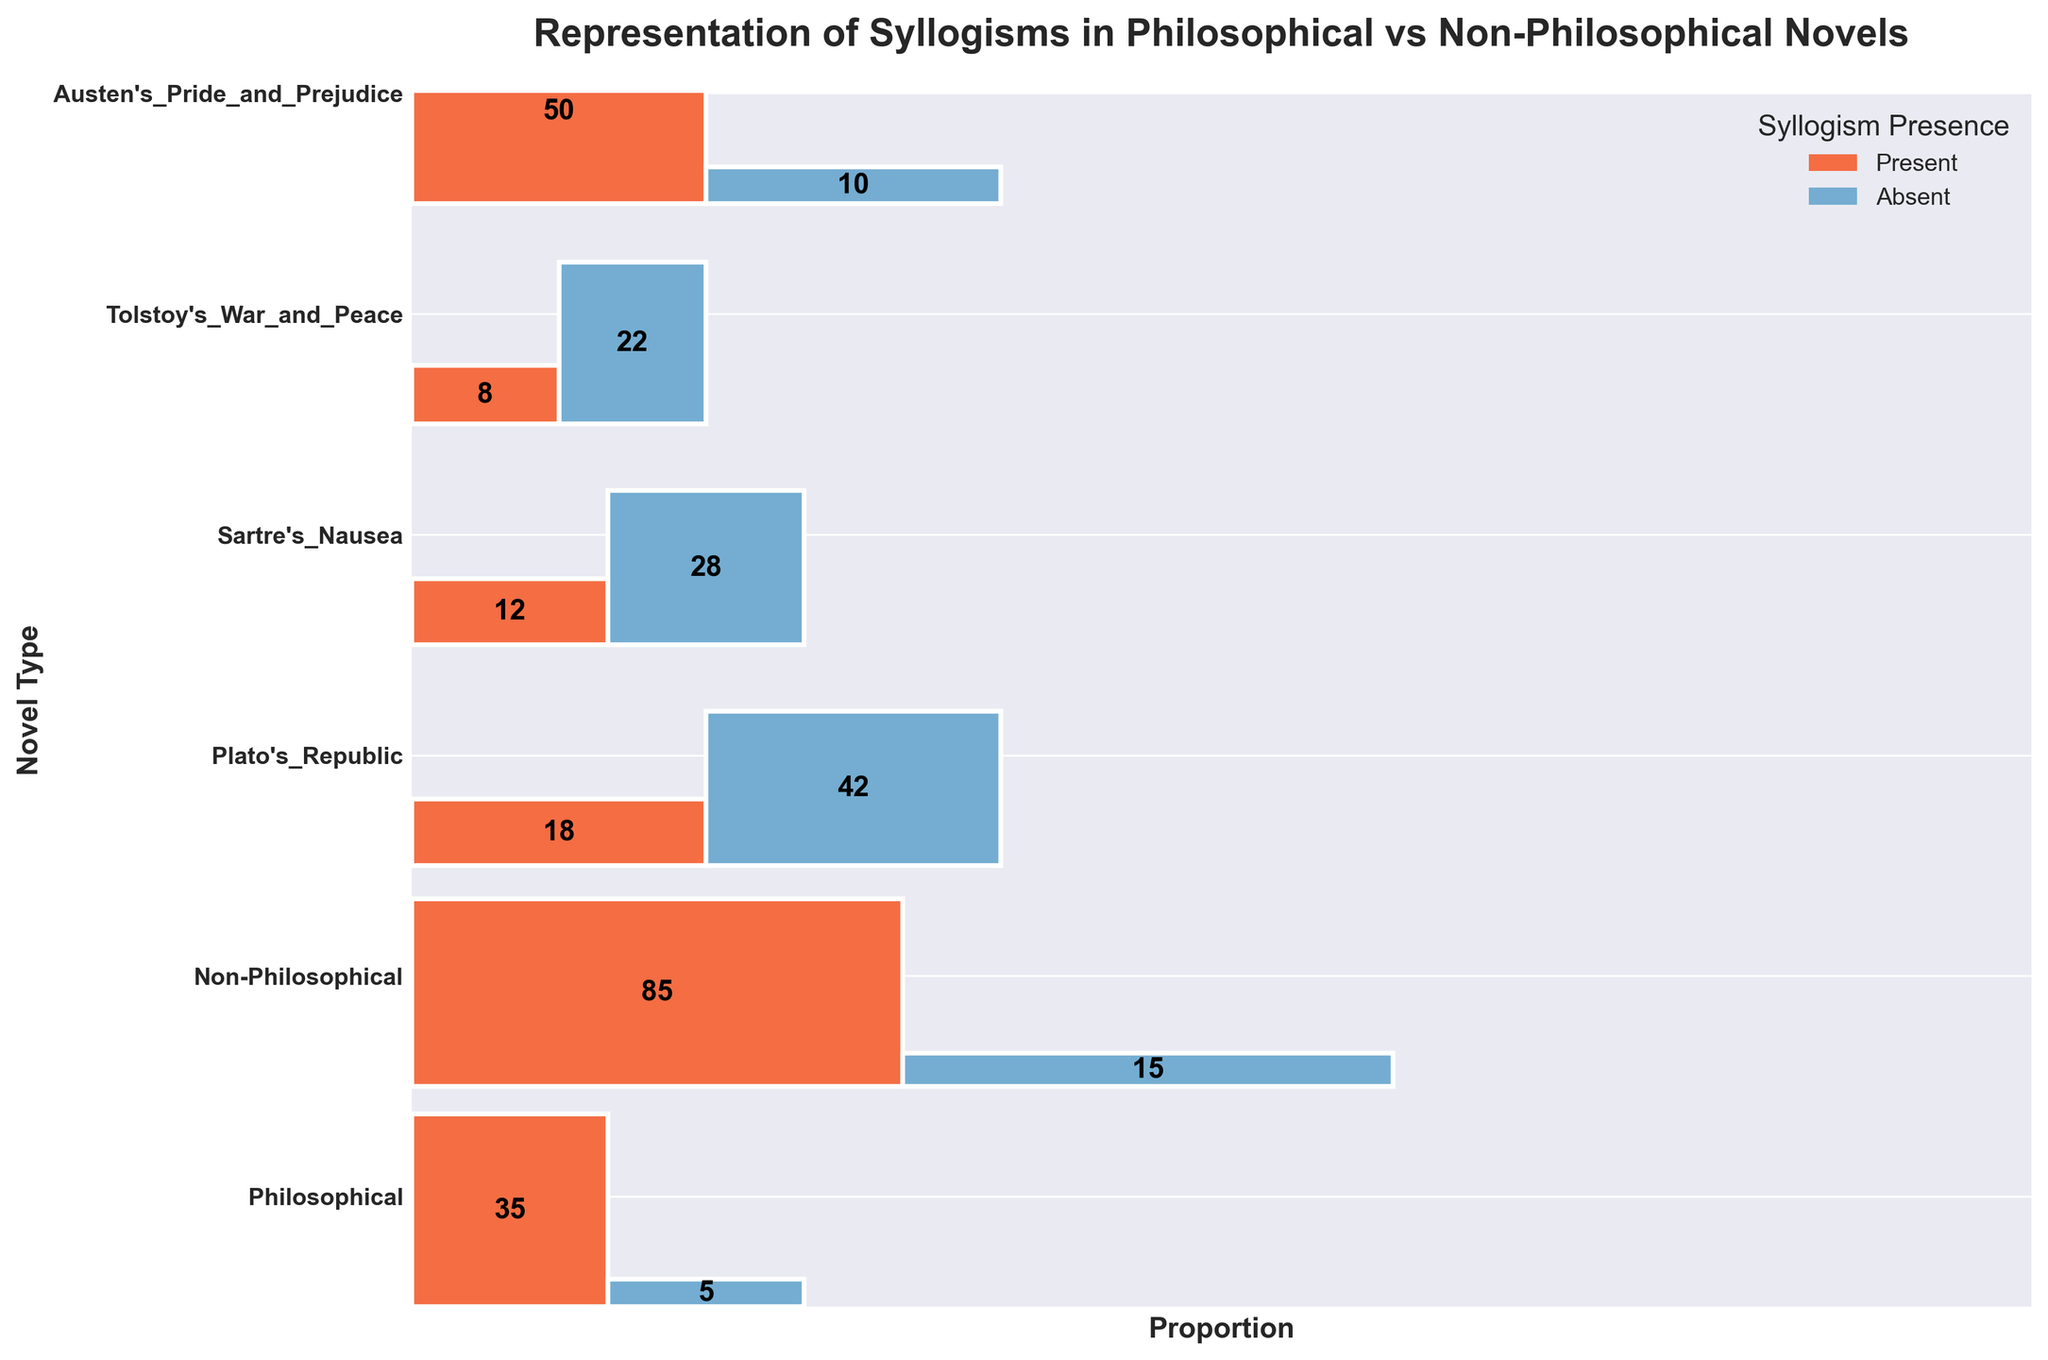What's the title of the figure? The title is displayed at the top of the plot, which reads 'Representation of Syllogisms in Philosophical vs Non-Philosophical Novels'.
Answer: Representation of Syllogisms in Philosophical vs Non-Philosophical Novels What novel is represented with the highest frequency of syllogisms present? By looking at the heights of rectangles within each row, 'Plato's Republic' shows the highest frequency, as more of the space is covered by the rectangle colored for syllogism presence.
Answer: Plato's Republic What is the proportion of syllogisms present in 'Sartre's Nausea'? The row for 'Sartre's Nausea' indicates that the light-colored rectangle is around twice as tall than that of the dark-colored, with 22 for present and 8 for absent, making the proportion 22/(22+8).
Answer: 0.73 What is the total frequency of novels with syllogisms present? Sum up the 'Present' frequencies of all novel types: 42 (Philosophical) + 15 (Non-Philosophical) + 28 (Plato's Republic) + 22 (Sartre's Nausea) + 10 (Tolstoy’s War and Peace) + 5 (Austen's Pride and Prejudice). This gives 122.
Answer: 122 Which type of novel has the greater proportion of syllogisms absent, Philosophical or Non-Philosophical? Examine the proportional widths of the rectangles for each novel type. Non-Philosophical has a larger ratio of syllogisms absent, with 85 absent versus 15 present.
Answer: Non-Philosophical How does the frequency of syllogism presence in 'Plato's Republic' compare to 'Tolstoy's War and Peace'? The rectangles show that 'Plato's Republic' has 28 while 'Tolstoy’s War and Peace' has 10, meaning 'Plato's Republic' has a higher frequency.
Answer: Plato's Republic Is there any novel category where syllogisms are more frequently absent than present? Check the heights of dark-colored rectangles compared to the light-colored ones. 'Tolstoy’s War and Peace' and 'Austen's Pride and Prejudice' show higher dark-colored rectangles, indicating higher frequency of syllogisms absent.
Answer: Yes What does the color representation in the plot signify? The caption and color legend indicate that the colors represent the presence (light color) and absence (dark color) of syllogisms in each novel type.
Answer: Presence and absence of syllogisms Comparing 'Sartre's Nausea' and 'Austen’s Pride and Prejudice,' which has a larger absolute frequency of syllogisms absent? 'Sartre's Nausea' has an absent frequency of 8, whereas 'Austen’s Pride and Prejudice' has 35, which is much larger.
Answer: Austen's Pride and Prejudice What is the total frequency of syllogisms absence across all novels? Sum the 'Absent' frequencies: 18 (Philosophical) + 85 (Non-Philosophical) + 12 (Plato's Republic) + 8 (Sartre's Nausea) + 50 (Tolstoy’s War and Peace) + 35 (Austen's Pride and Prejudice) gives 208.
Answer: 208 